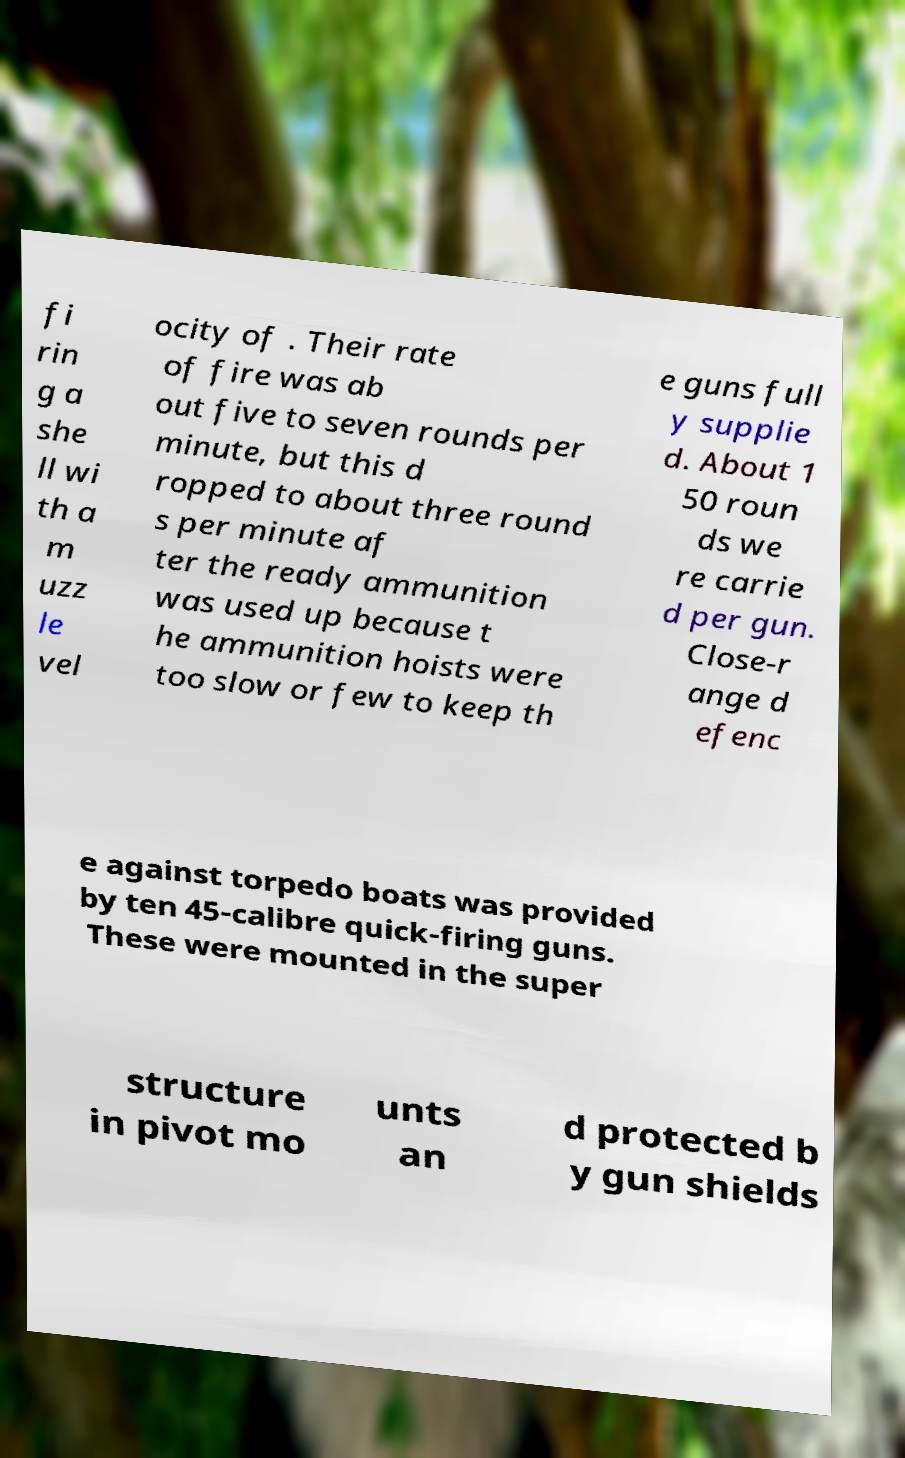Can you read and provide the text displayed in the image?This photo seems to have some interesting text. Can you extract and type it out for me? fi rin g a she ll wi th a m uzz le vel ocity of . Their rate of fire was ab out five to seven rounds per minute, but this d ropped to about three round s per minute af ter the ready ammunition was used up because t he ammunition hoists were too slow or few to keep th e guns full y supplie d. About 1 50 roun ds we re carrie d per gun. Close-r ange d efenc e against torpedo boats was provided by ten 45-calibre quick-firing guns. These were mounted in the super structure in pivot mo unts an d protected b y gun shields 